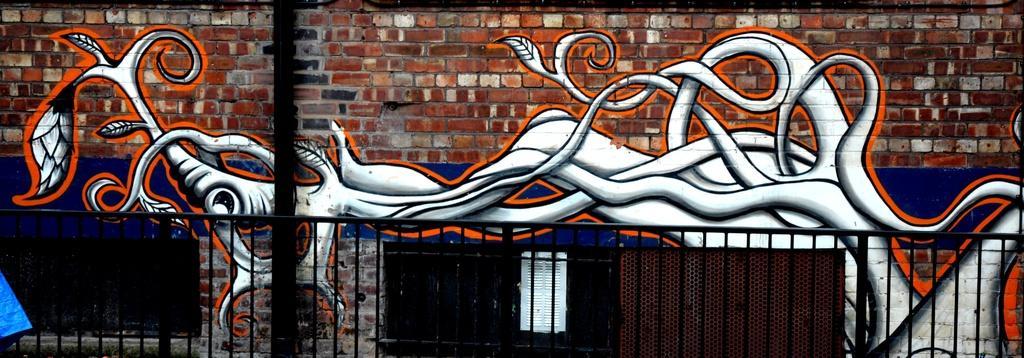How would you summarize this image in a sentence or two? In this picture I can see there is a brick wall and there is a graffiti painting on it. There is a black color railing in front of it and a blue color object at the left side bottom. 